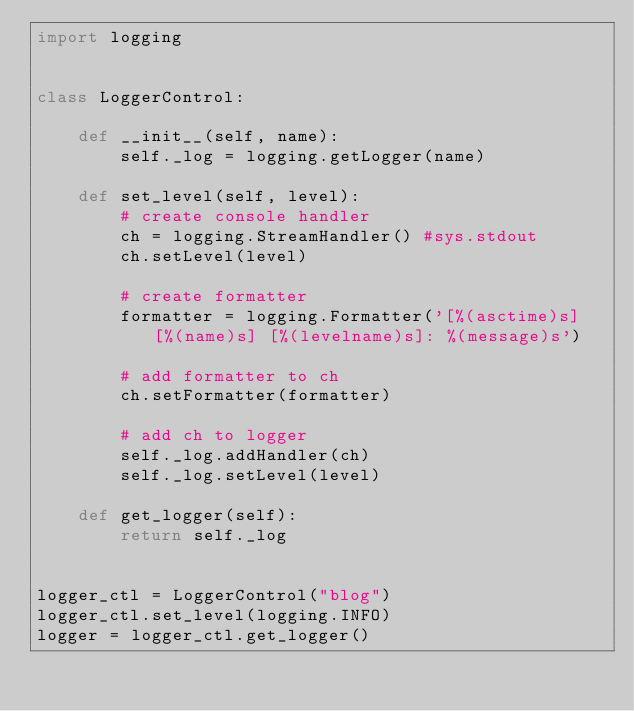<code> <loc_0><loc_0><loc_500><loc_500><_Python_>import logging


class LoggerControl:

    def __init__(self, name):
        self._log = logging.getLogger(name)

    def set_level(self, level):
        # create console handler
        ch = logging.StreamHandler() #sys.stdout
        ch.setLevel(level)

        # create formatter
        formatter = logging.Formatter('[%(asctime)s] [%(name)s] [%(levelname)s]: %(message)s')

        # add formatter to ch
        ch.setFormatter(formatter)

        # add ch to logger
        self._log.addHandler(ch)
        self._log.setLevel(level)

    def get_logger(self):
        return self._log


logger_ctl = LoggerControl("blog")
logger_ctl.set_level(logging.INFO)
logger = logger_ctl.get_logger()

</code> 